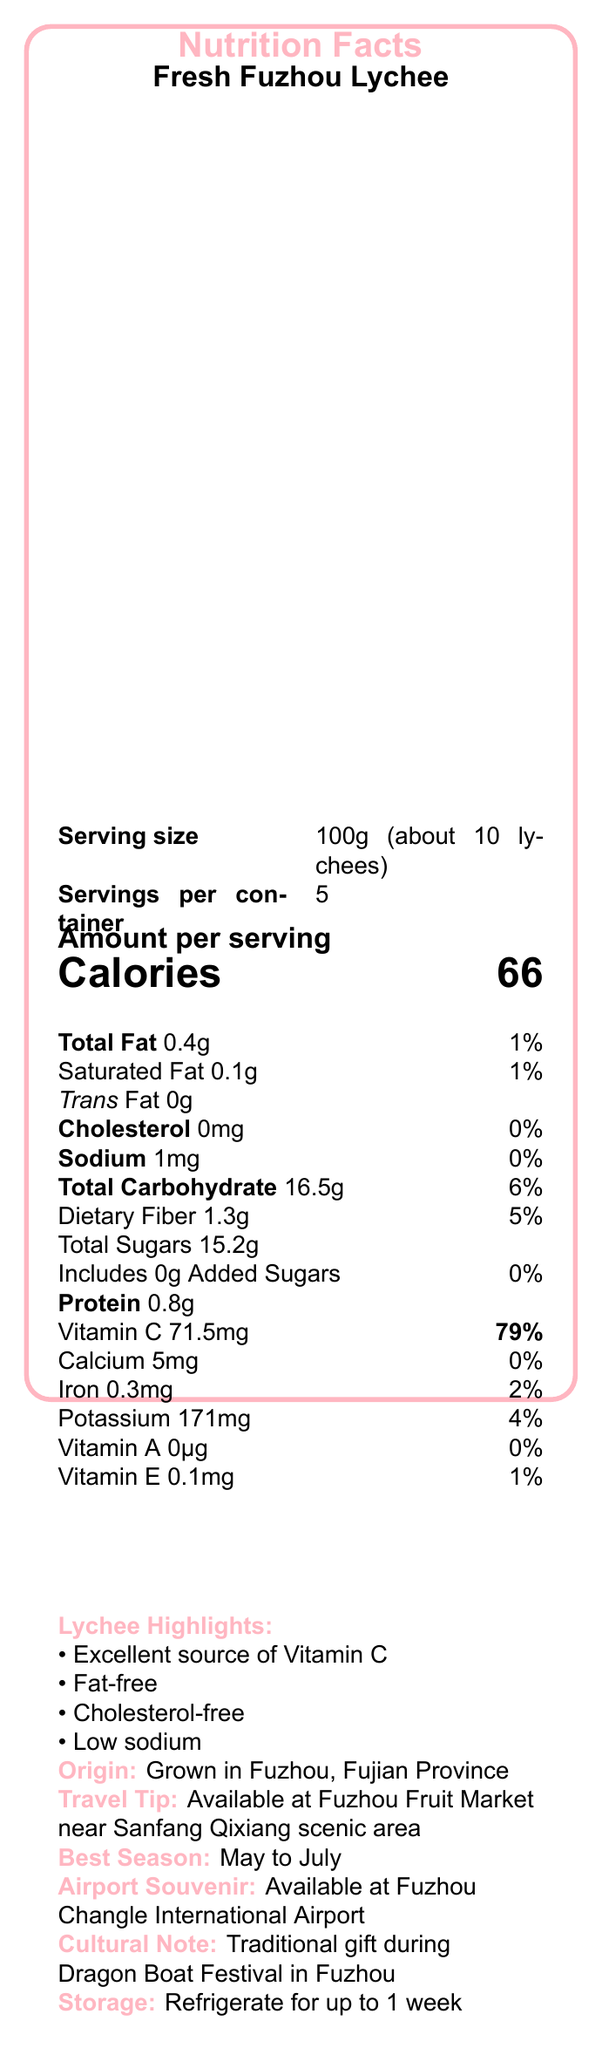what is the serving size for Fresh Fuzhou Lychee? The serving size is stated clearly as 100g (about 10 lychees) in the document.
Answer: 100g (about 10 lychees) How many calories are there per serving of Fresh Fuzhou Lychee? The document specifies that there are 66 calories per serving.
Answer: 66 calories Which nutrient in Fresh Fuzhou Lychee has the highest daily value percentage? The vitamin C content provides the highest daily value percentage at 79%.
Answer: Vitamin C (79%) How much total fat does one serving of Fresh Fuzhou Lychee contain? The document states that one serving contains 0.4g of total fat.
Answer: 0.4g What is the best season to enjoy Fresh Fuzhou Lychee? The document mentions that the best season to enjoy it is from May to July.
Answer: May to July What is the origin of Fresh Fuzhou Lychee? The document explicitly states that the Fresh Fuzhou Lychee is grown in Fuzhou, Fujian Province.
Answer: Grown in Fuzhou, Fujian Province Is it true that Fresh Fuzhou Lychee is a good source of Vitamin C? The document lists “Excellent source of Vitamin C” under Lychee Highlights.
Answer: Yes Which of the following statements is true about Fresh Fuzhou Lychee? A. It is high in sodium. B. It contains trans fat. C. It is cholesterol-free. Under Lychee Highlights, it's mentioned that the lychee is cholesterol-free.
Answer: C. It is cholesterol-free How much potassium is there per serving of Fresh Fuzhou Lychee? A. 1mg B. 171mg C. 5mg D. 0mg The document states that there are 171mg of potassium per serving.
Answer: B. 171mg Where can Fresh Fuzhou Lychee be purchased as a last-minute souvenir? A. Fuzhou Fruit Market B. Sanfang Qixiang scenic area C. Fuzhou Changle International Airport D. Dragon Boat Festival The document notes that the lychees can be purchased at Fuzhou Changle International Airport for a last-minute souvenir.
Answer: C. Fuzhou Changle International Airport Does Fresh Fuzhou Lychee contain any added sugars? The document specifies that there are 0g of added sugars in Fresh Fuzhou Lychee.
Answer: No Summarize the nutrition and travel-relevant information provided for Fresh Fuzhou Lychee. The document provides a comprehensive overview, detailing nutritional facts, geographical origin, storage tips, and cultural significance, making it easier for tourists and consumers to understand its benefits and availability.
Answer: Fresh Fuzhou Lychee, grown in Fuzhou, Fujian Province, is an excellent source of Vitamin C with low calories, minimal fat, and no cholesterol or trans fat. It's available at the Fuzhou Fruit Market and Fuzhou Changle International Airport, especially during May to July. It is a traditional gift for the Dragon Boat Festival and can be stored in the refrigerator for up to a week for optimal freshness. What is the total weight of the container of Fresh Fuzhou Lychee if each serving is 100g and there are 5 servings? The document states that there are 5 servings per container, with each serving being 100g. Hence, 100g x 5 servings = 500g.
Answer: 500g What is the main festival during which Fresh Fuzhou Lychee is traditionally gifted? The document notes its cultural significance, particularly as a traditional gift during the Dragon Boat Festival.
Answer: Dragon Boat Festival What is the vitamin A content in Fresh Fuzhou Lychee? The document mentions a content of 0μg for Vitamin A, which is essentially none, but the answer implies the need for clarification that it is absent rather than not provided.
Answer: Cannot be determined 